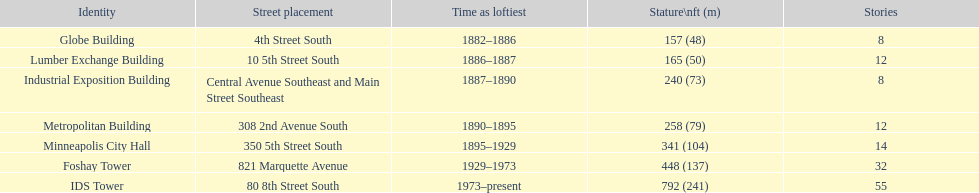Which building has 8 floors and is 240 ft tall? Industrial Exposition Building. Would you be able to parse every entry in this table? {'header': ['Identity', 'Street placement', 'Time as loftiest', 'Stature\\nft (m)', 'Stories'], 'rows': [['Globe Building', '4th Street South', '1882–1886', '157 (48)', '8'], ['Lumber Exchange Building', '10 5th Street South', '1886–1887', '165 (50)', '12'], ['Industrial Exposition Building', 'Central Avenue Southeast and Main Street Southeast', '1887–1890', '240 (73)', '8'], ['Metropolitan Building', '308 2nd Avenue South', '1890–1895', '258 (79)', '12'], ['Minneapolis City Hall', '350 5th Street South', '1895–1929', '341 (104)', '14'], ['Foshay Tower', '821 Marquette Avenue', '1929–1973', '448 (137)', '32'], ['IDS Tower', '80 8th Street South', '1973–present', '792 (241)', '55']]} 